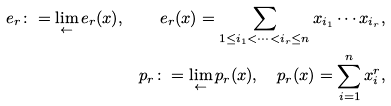<formula> <loc_0><loc_0><loc_500><loc_500>e _ { r } \colon = \lim _ { \leftarrow } e _ { r } ( x ) , \quad e _ { r } ( x ) = \sum _ { 1 \leq i _ { 1 } < \cdots < i _ { r } \leq n } x _ { i _ { 1 } } \cdots x _ { i _ { r } } , \\ p _ { r } \colon = \lim _ { \leftarrow } p _ { r } ( x ) , \quad p _ { r } ( x ) = \sum _ { i = 1 } ^ { n } x _ { i } ^ { r } ,</formula> 